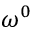<formula> <loc_0><loc_0><loc_500><loc_500>\omega ^ { 0 }</formula> 